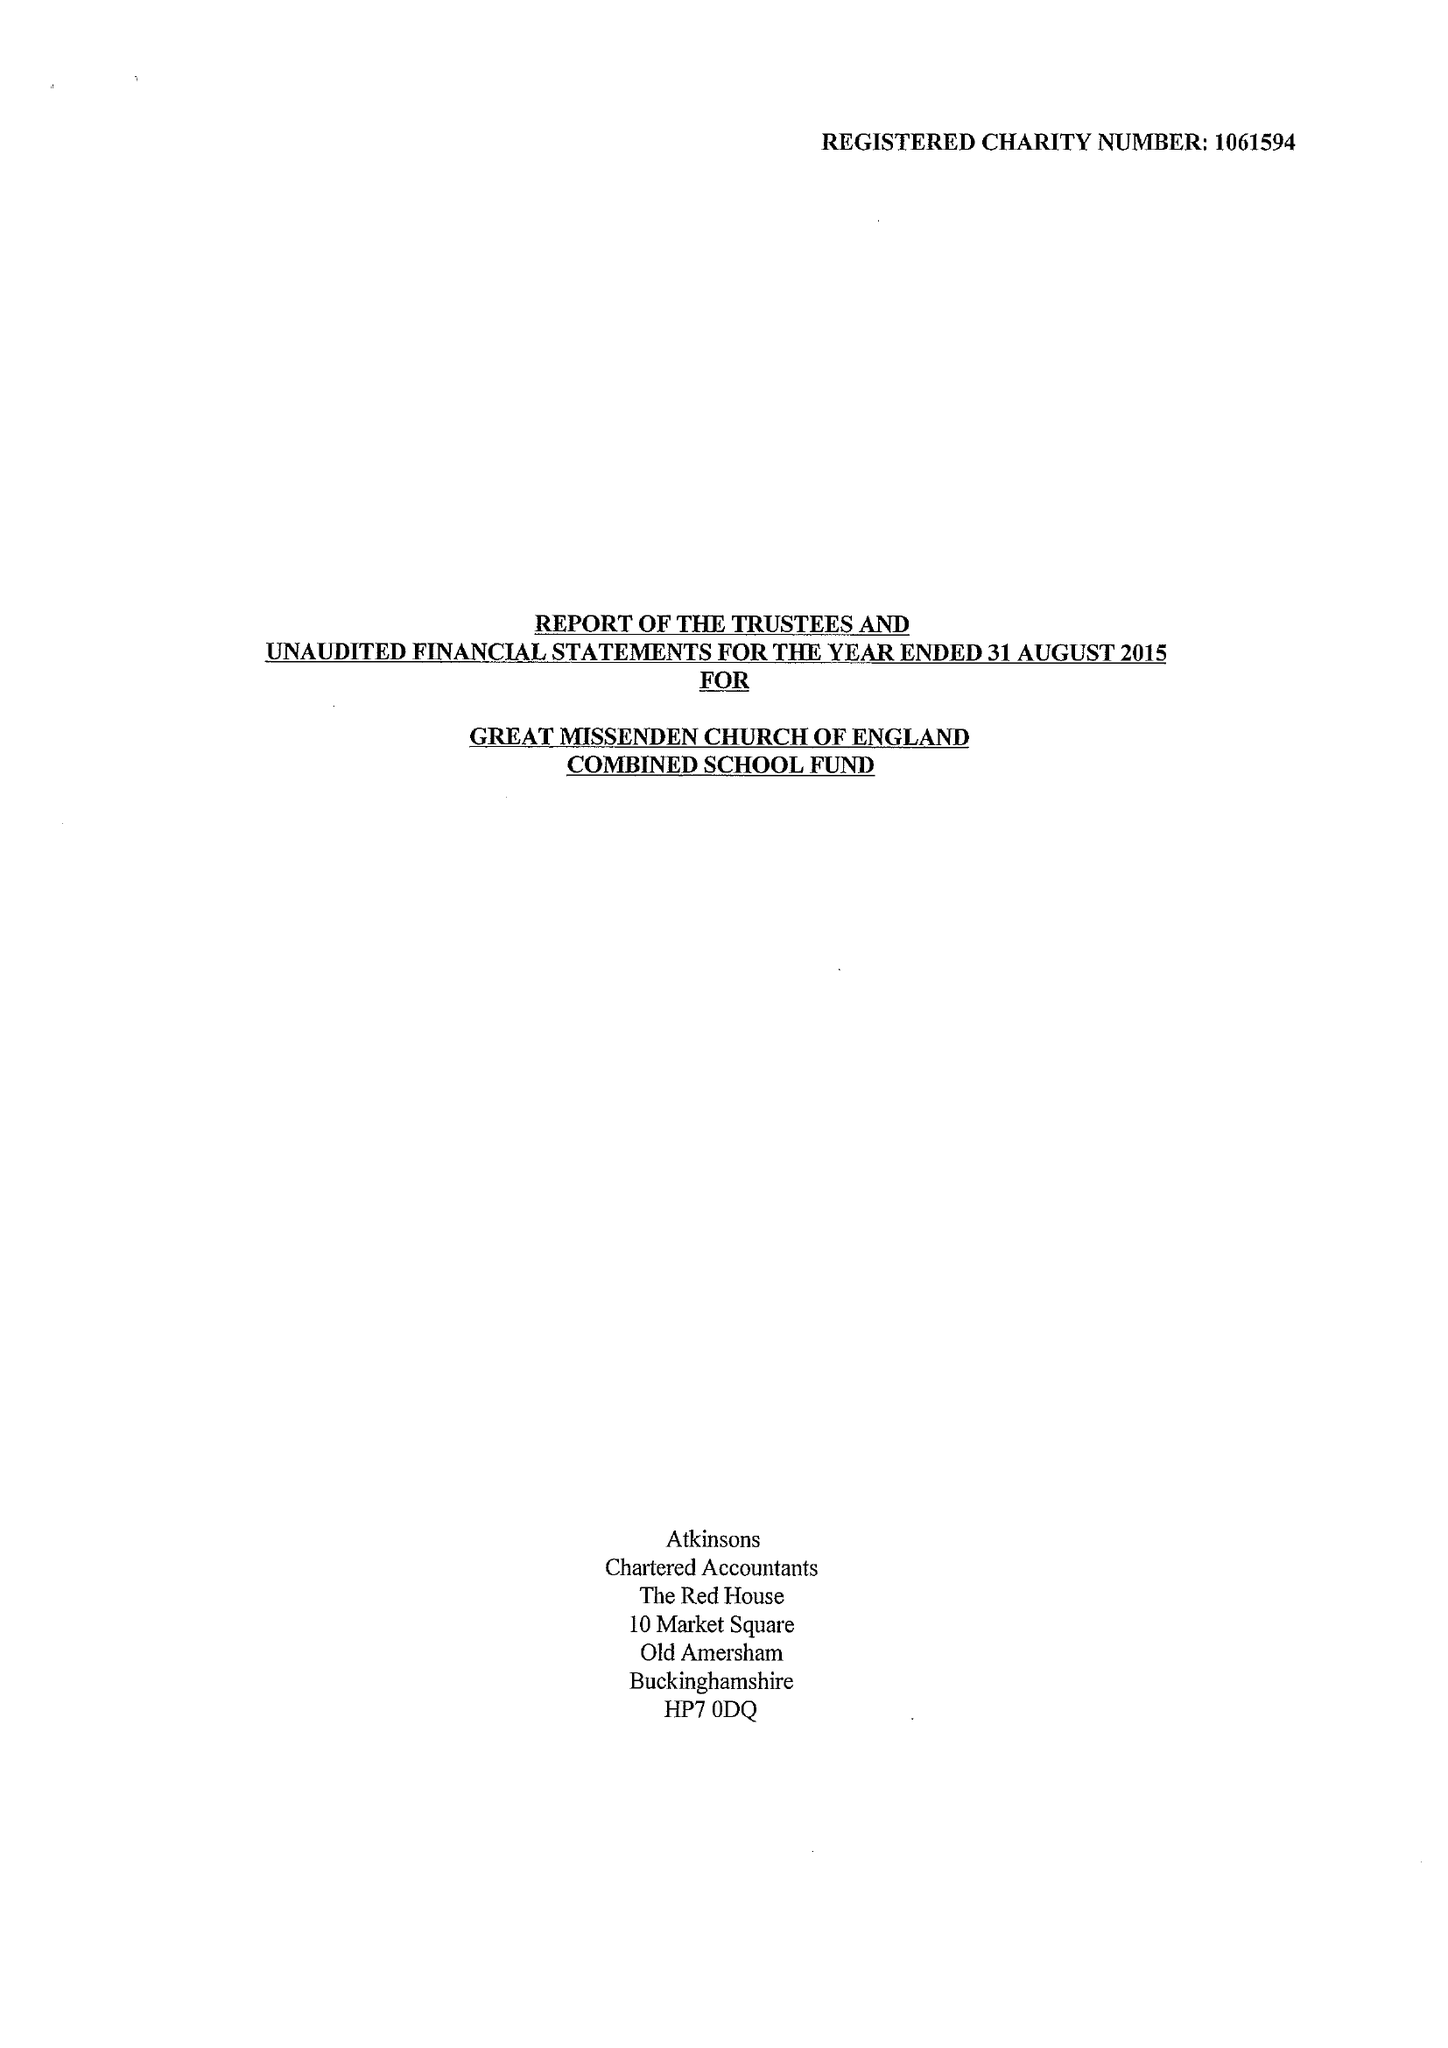What is the value for the address__street_line?
Answer the question using a single word or phrase. CHURCH STREET 